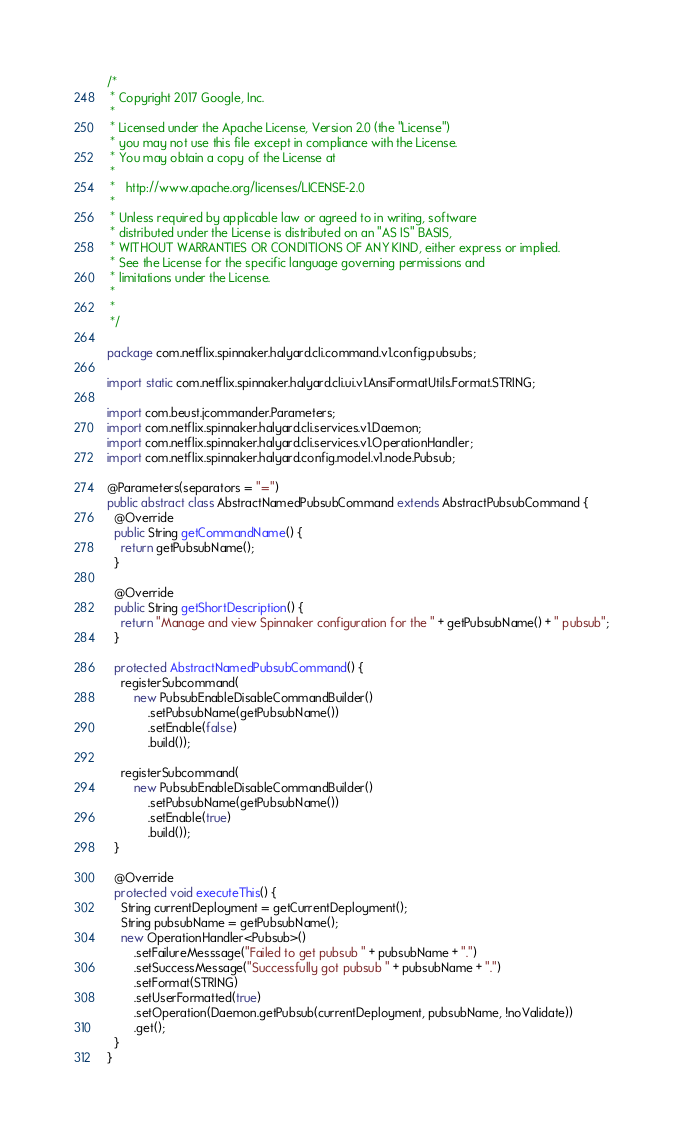<code> <loc_0><loc_0><loc_500><loc_500><_Java_>/*
 * Copyright 2017 Google, Inc.
 *
 * Licensed under the Apache License, Version 2.0 (the "License")
 * you may not use this file except in compliance with the License.
 * You may obtain a copy of the License at
 *
 *   http://www.apache.org/licenses/LICENSE-2.0
 *
 * Unless required by applicable law or agreed to in writing, software
 * distributed under the License is distributed on an "AS IS" BASIS,
 * WITHOUT WARRANTIES OR CONDITIONS OF ANY KIND, either express or implied.
 * See the License for the specific language governing permissions and
 * limitations under the License.
 *
 *
 */

package com.netflix.spinnaker.halyard.cli.command.v1.config.pubsubs;

import static com.netflix.spinnaker.halyard.cli.ui.v1.AnsiFormatUtils.Format.STRING;

import com.beust.jcommander.Parameters;
import com.netflix.spinnaker.halyard.cli.services.v1.Daemon;
import com.netflix.spinnaker.halyard.cli.services.v1.OperationHandler;
import com.netflix.spinnaker.halyard.config.model.v1.node.Pubsub;

@Parameters(separators = "=")
public abstract class AbstractNamedPubsubCommand extends AbstractPubsubCommand {
  @Override
  public String getCommandName() {
    return getPubsubName();
  }

  @Override
  public String getShortDescription() {
    return "Manage and view Spinnaker configuration for the " + getPubsubName() + " pubsub";
  }

  protected AbstractNamedPubsubCommand() {
    registerSubcommand(
        new PubsubEnableDisableCommandBuilder()
            .setPubsubName(getPubsubName())
            .setEnable(false)
            .build());

    registerSubcommand(
        new PubsubEnableDisableCommandBuilder()
            .setPubsubName(getPubsubName())
            .setEnable(true)
            .build());
  }

  @Override
  protected void executeThis() {
    String currentDeployment = getCurrentDeployment();
    String pubsubName = getPubsubName();
    new OperationHandler<Pubsub>()
        .setFailureMesssage("Failed to get pubsub " + pubsubName + ".")
        .setSuccessMessage("Successfully got pubsub " + pubsubName + ".")
        .setFormat(STRING)
        .setUserFormatted(true)
        .setOperation(Daemon.getPubsub(currentDeployment, pubsubName, !noValidate))
        .get();
  }
}
</code> 